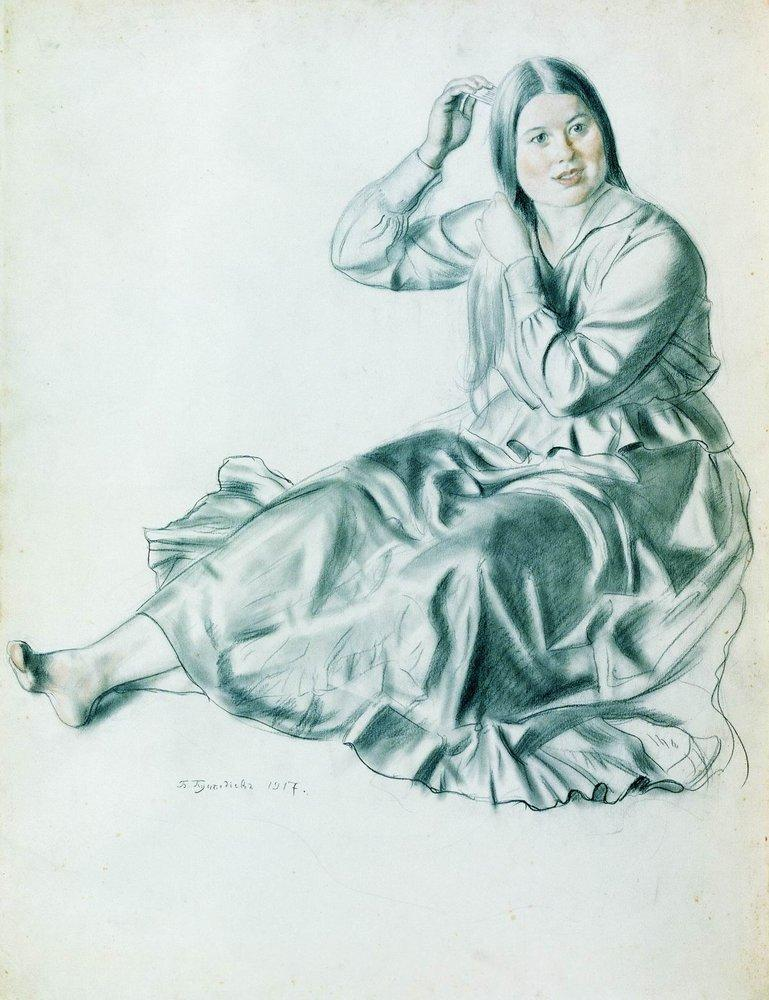If the image could come to life, describe the scene that would unfold. As the image springs to life, the woman continues her gentle grooming, humming a soft, melodious tune. Rays of sunlight filter through the window, illuminating her and casting a warm glow around the room. Her dress rustles softly as it drapes around her legs, and the air fills with the faint scent of lavender from a vase nearby. Suddenly, a soft knock interrupts her peaceful morning, and she rises gracefully to answer the door. A messenger hands her a letter – the expression of tranquility on her face briefly shifts to one of curiosity and anticipation as she takes the letter and begins to read, her eyebrows lifting slightly as she absorbs its contents. The scene then fades, leaving behind the lingering sense of a story deeply woven into her serene existence. 